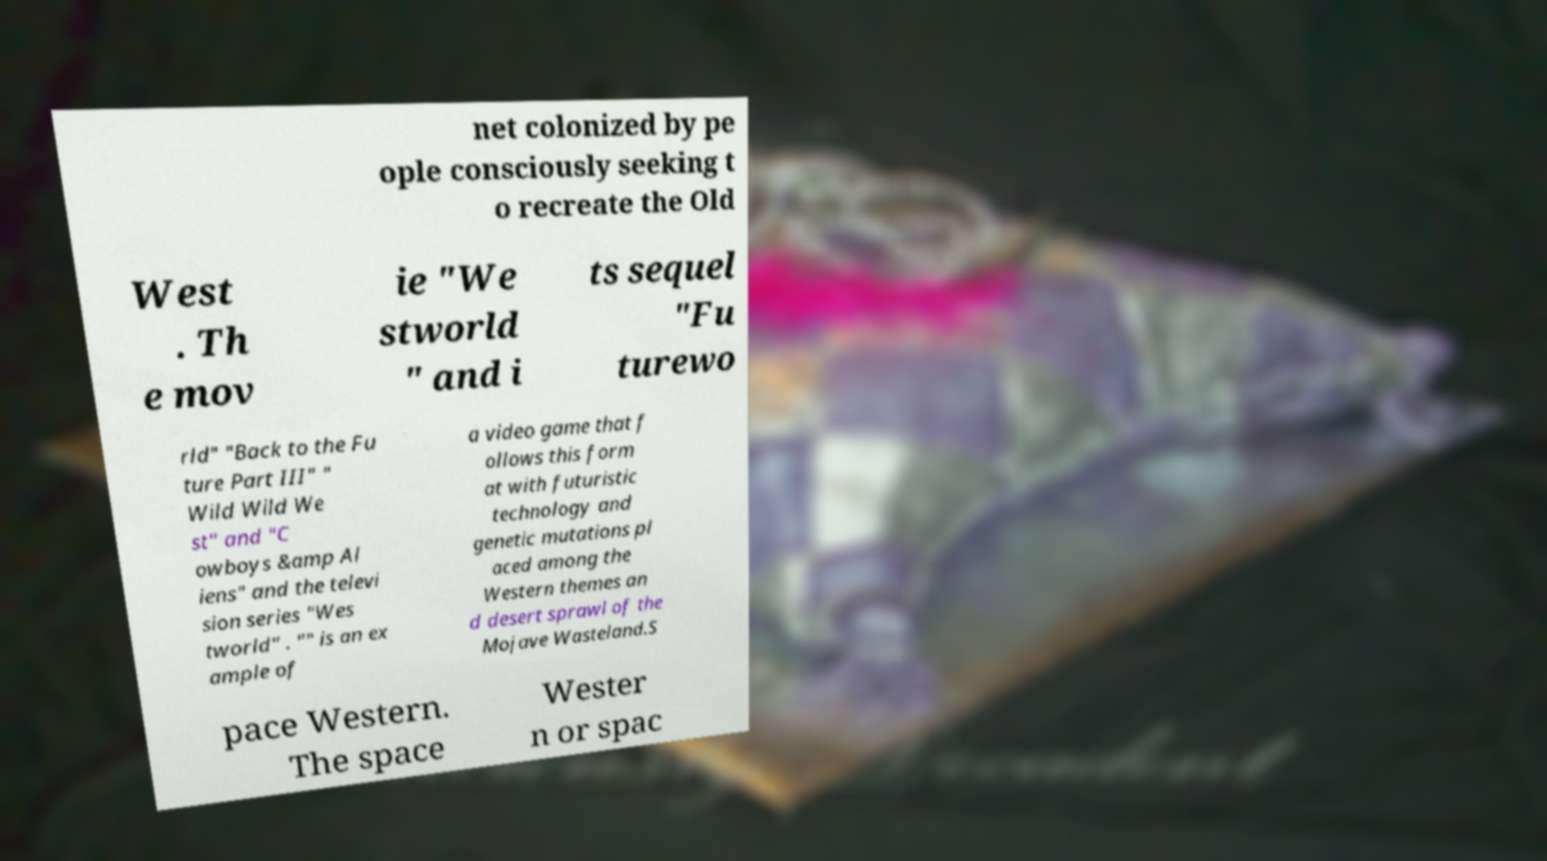What messages or text are displayed in this image? I need them in a readable, typed format. net colonized by pe ople consciously seeking t o recreate the Old West . Th e mov ie "We stworld " and i ts sequel "Fu turewo rld" "Back to the Fu ture Part III" " Wild Wild We st" and "C owboys &amp Al iens" and the televi sion series "Wes tworld" . "" is an ex ample of a video game that f ollows this form at with futuristic technology and genetic mutations pl aced among the Western themes an d desert sprawl of the Mojave Wasteland.S pace Western. The space Wester n or spac 